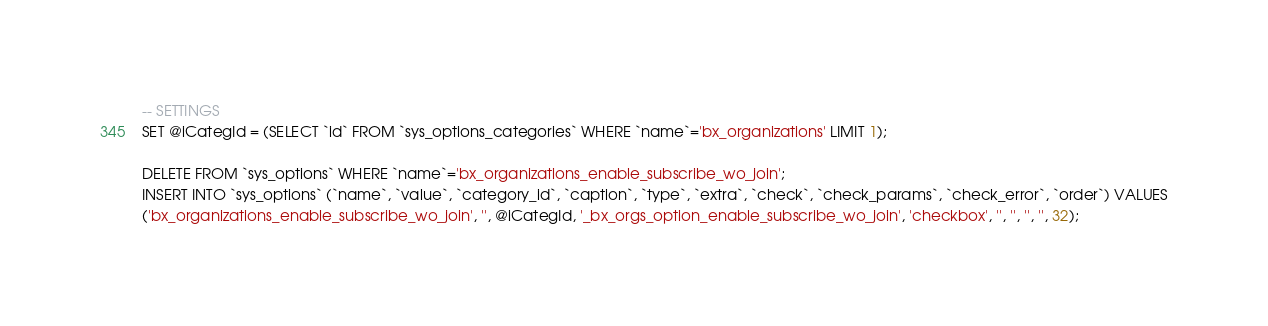<code> <loc_0><loc_0><loc_500><loc_500><_SQL_>-- SETTINGS
SET @iCategId = (SELECT `id` FROM `sys_options_categories` WHERE `name`='bx_organizations' LIMIT 1);

DELETE FROM `sys_options` WHERE `name`='bx_organizations_enable_subscribe_wo_join';
INSERT INTO `sys_options` (`name`, `value`, `category_id`, `caption`, `type`, `extra`, `check`, `check_params`, `check_error`, `order`) VALUES
('bx_organizations_enable_subscribe_wo_join', '', @iCategId, '_bx_orgs_option_enable_subscribe_wo_join', 'checkbox', '', '', '', '', 32);
</code> 